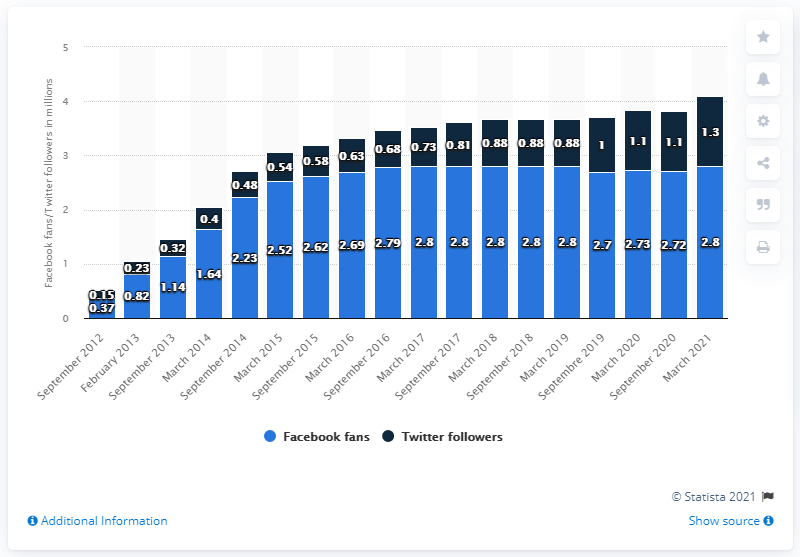Indicate a few pertinent items in this graphic. As of September 2012, the Brooklyn Nets had a Facebook page. In March 2021, the Brooklyn Nets basketball team had 2,800 fans on their Facebook page. 